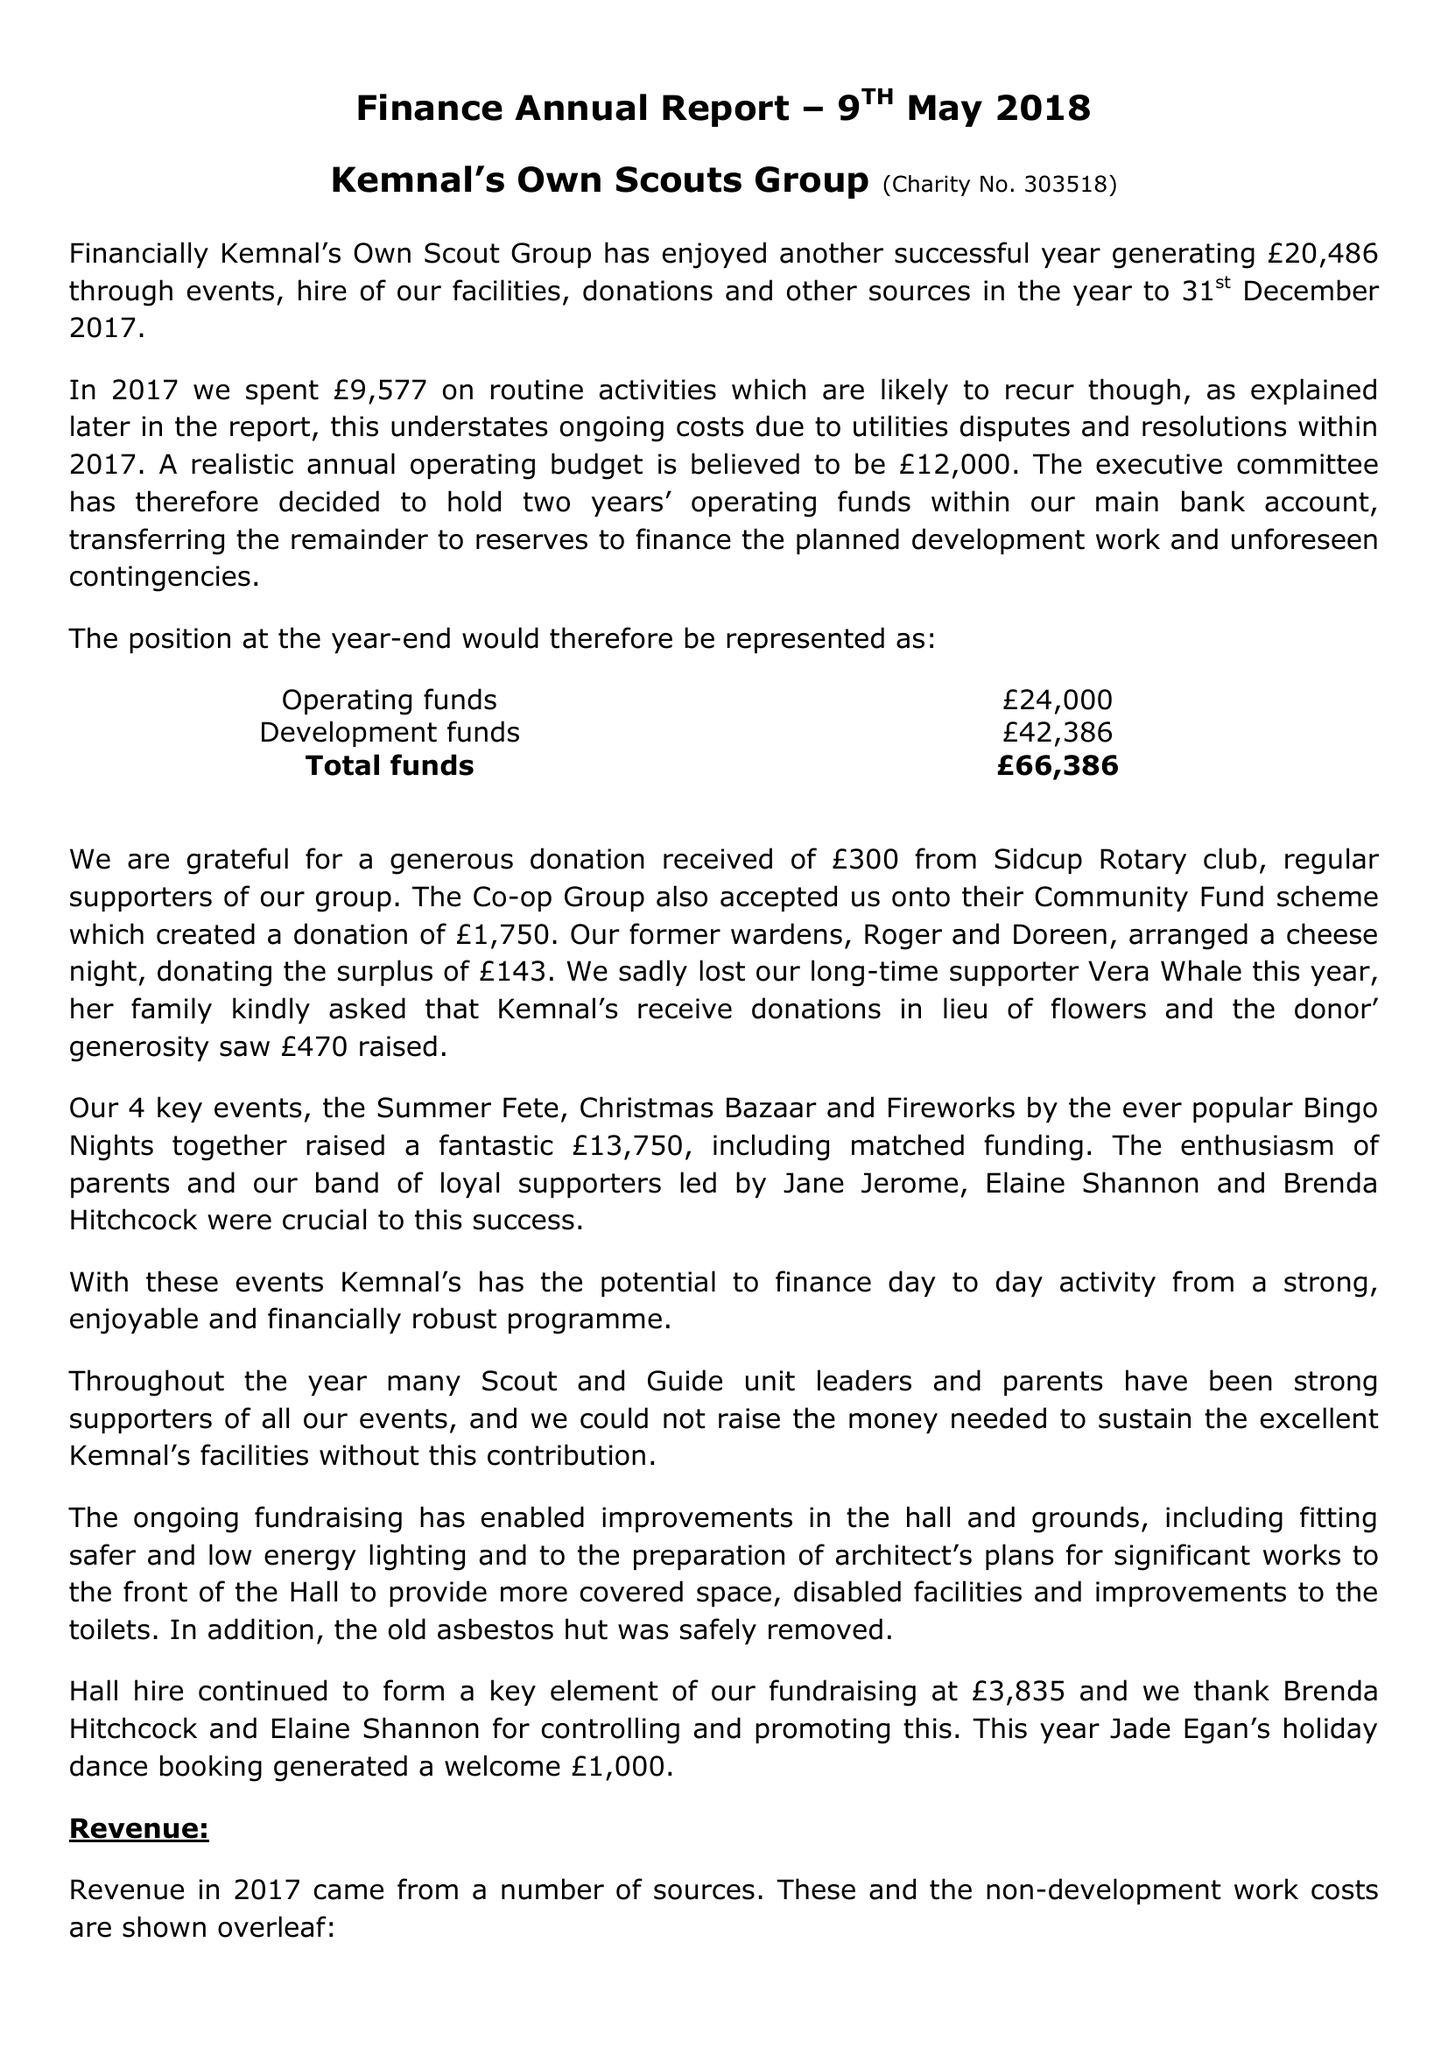What is the value for the address__street_line?
Answer the question using a single word or phrase. 13 PARKHILL ROAD 